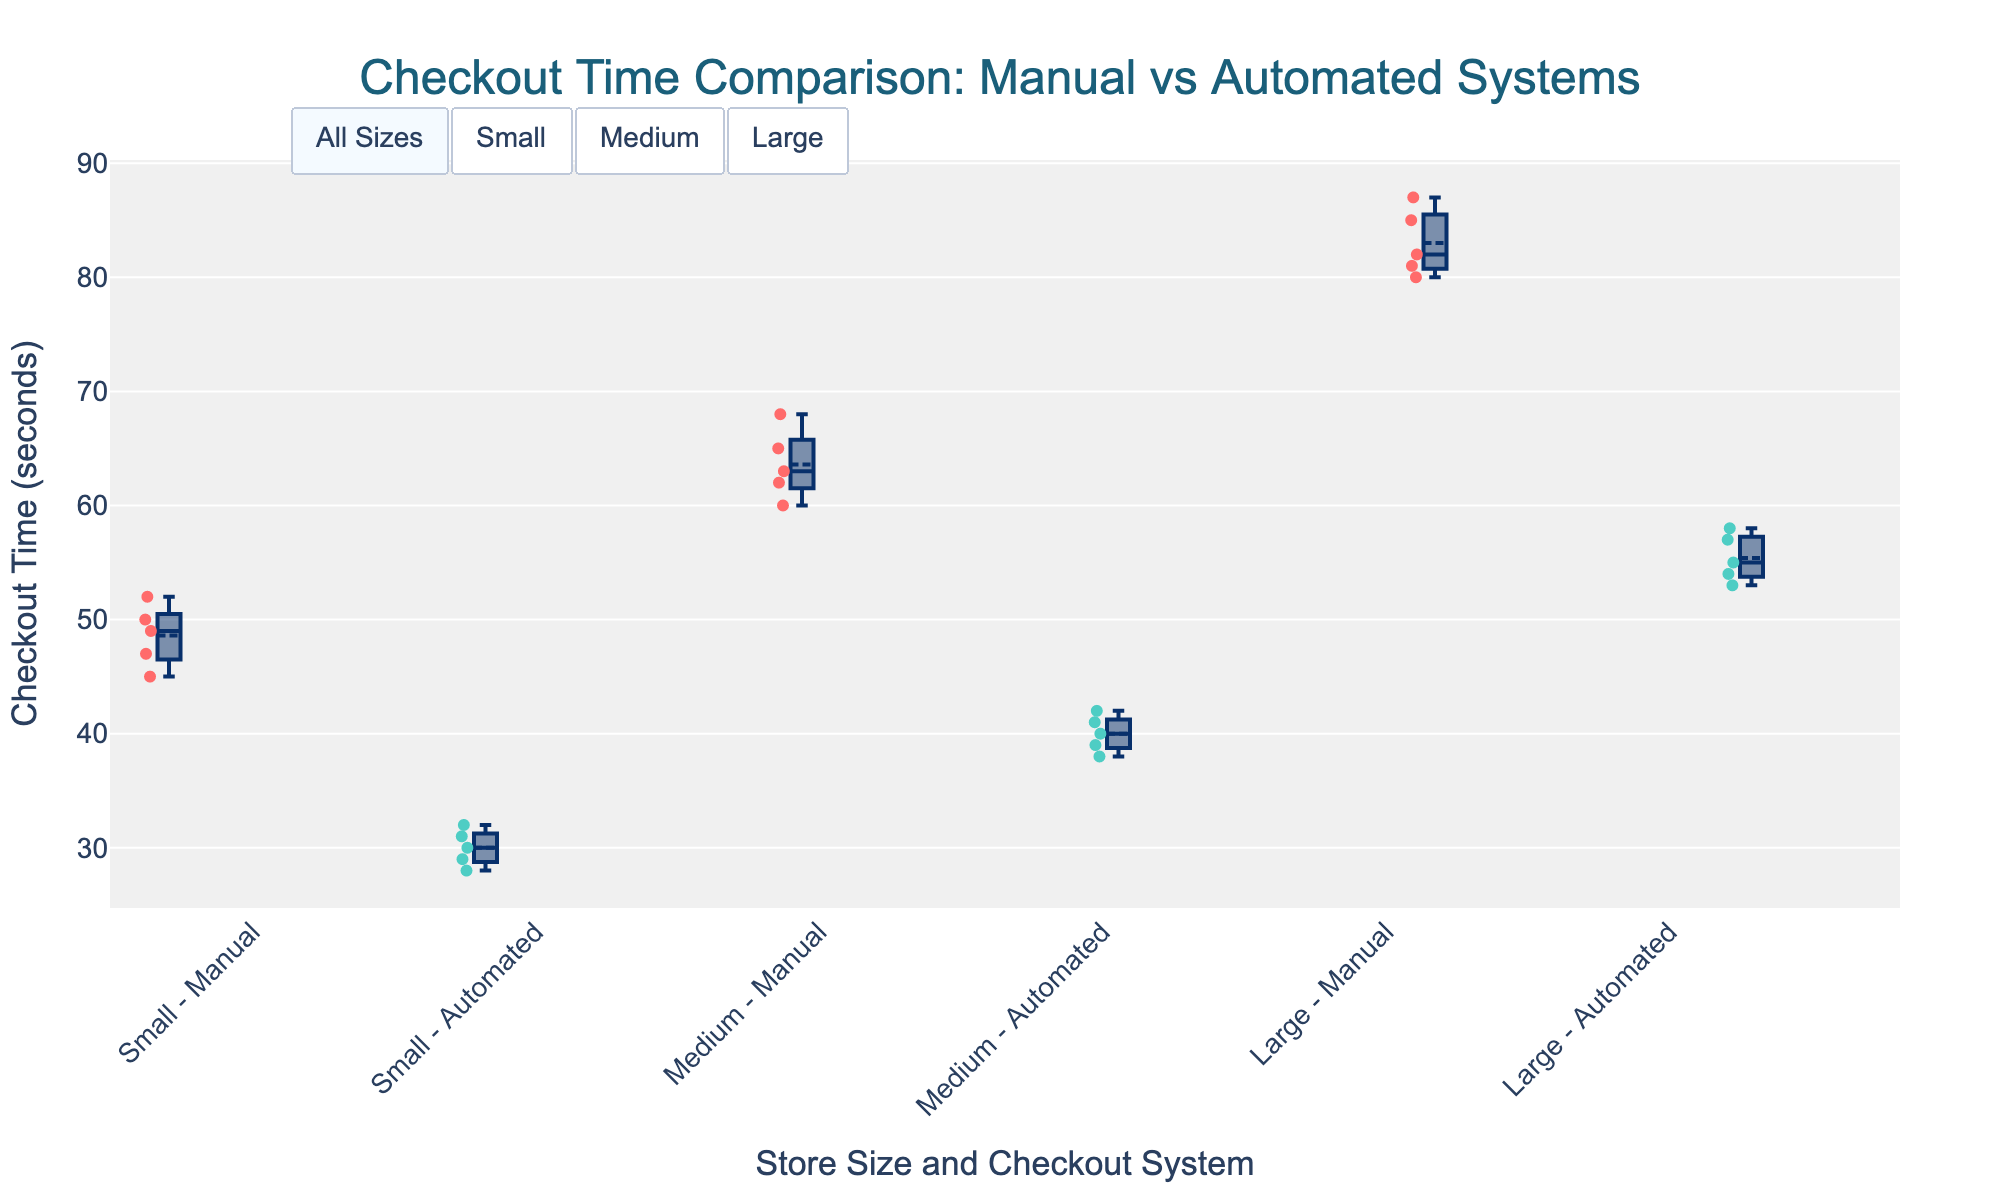What is the title of the plot? The title is displayed prominently at the top of the plot, indicating what the plot shows.
Answer: Checkout Time Comparison: Manual vs Automated Systems What is the average checkout time for automated systems in small stores? The average is found by summing all checkout times for automated systems in small stores and then dividing by the number of data points. (30 + 32 + 28 + 31 + 29) / 5 = 30
Answer: 30 How many data points are there for manual checkout systems in medium stores? Count the individual data points for manual checkout systems in medium stores. There are 5 values listed under this category.
Answer: 5 What is the difference between the median checkout times of manual and automated systems in large stores? Find the median value (middle value) for both manual and automated checkout times in large stores. Subtract the median of the automated system from the manual system. Median of manual = 82, Median of automated = 55, Difference = 82 - 55
Answer: 27 Which store size shows the greatest reduction in checkout time when using automated systems compared to manual systems? Calculate the difference in average checkout times for each store size and compare them. Small = 45.5 - 30 = 15.5, Medium = 63.6 - 40 = 23.6, Large = 83 - 55.4 = 27.6
Answer: Large How is the checkout time distributed for manual systems in small stores? The box plot for manual systems in small stores shows the distribution. Most values range between 45 and 52 seconds, with a median around 49 seconds.
Answer: 45-52 seconds, median around 49 Are automated systems consistently faster than manual systems across all store sizes? Compare the checkout times shown in the box plots for both systems across small, medium, and large stores. Automated systems have consistently lower checkout times.
Answer: Yes What is the range of checkout times for automated systems in medium stores? The range is the difference between the maximum and minimum values in the automated systems for medium stores. Max = 42, Min = 38, Range = 42 - 38
Answer: 4 Which manual system in which store size has the highest median checkout time? Compare the medians of the manual system across all store sizes. The large store has the highest median checkout time at 82 seconds.
Answer: Large How much time is saved on average when using automated systems in medium stores compared to manual systems? Calculate the difference between the average checkout time of automated and manual systems in medium stores. Manual = 63.6, Automated = 40, Difference = 63.6 - 40
Answer: 23.6 